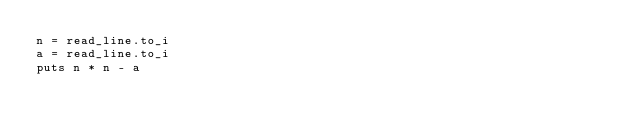<code> <loc_0><loc_0><loc_500><loc_500><_Crystal_>n = read_line.to_i
a = read_line.to_i
puts n * n - a
</code> 